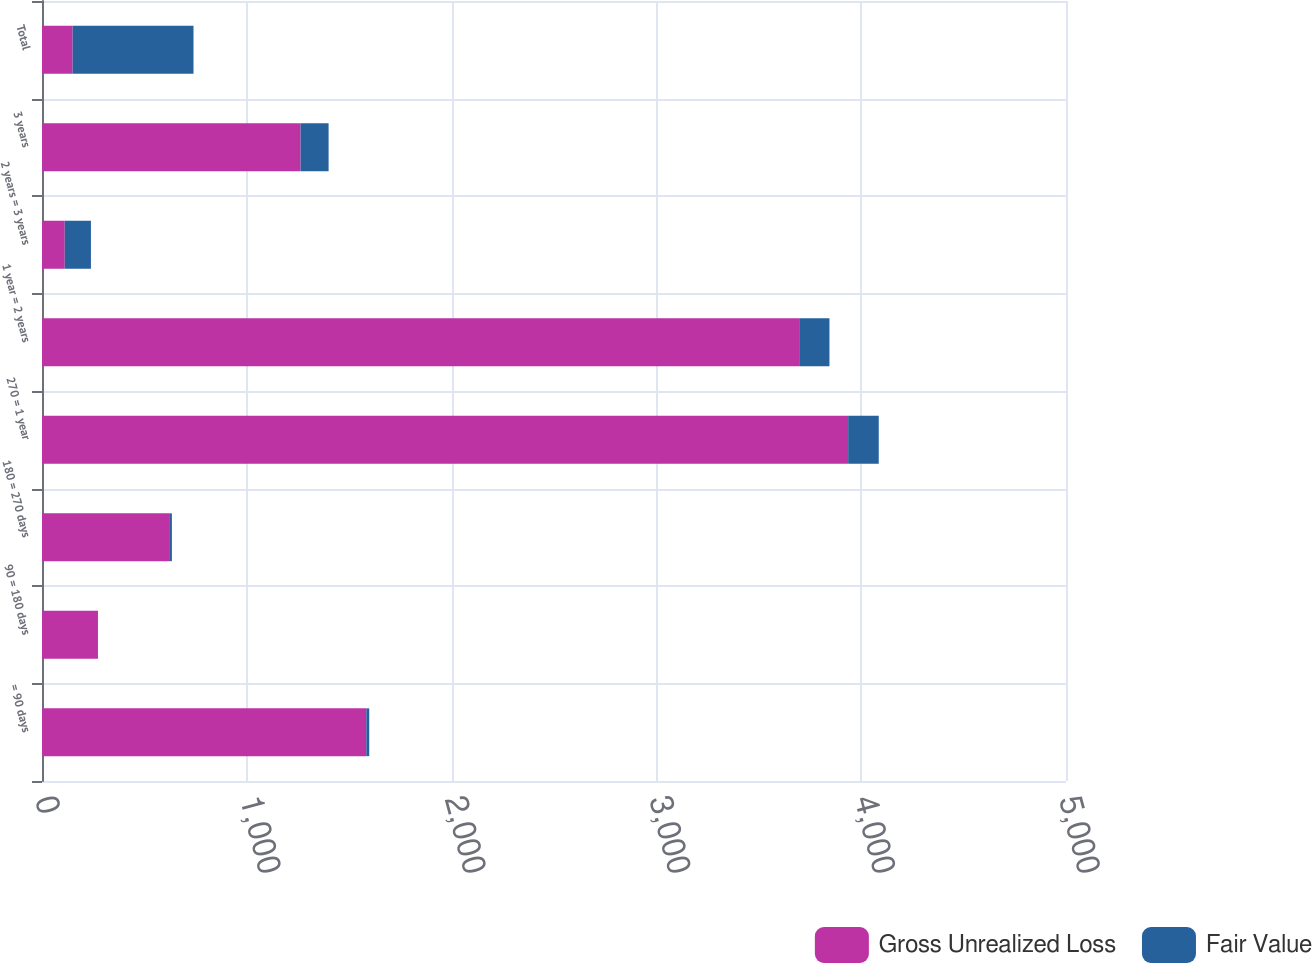Convert chart. <chart><loc_0><loc_0><loc_500><loc_500><stacked_bar_chart><ecel><fcel>= 90 days<fcel>90 = 180 days<fcel>180 = 270 days<fcel>270 = 1 year<fcel>1 year = 2 years<fcel>2 years = 3 years<fcel>3 years<fcel>Total<nl><fcel>Gross Unrealized Loss<fcel>1583.4<fcel>268.7<fcel>624.6<fcel>3936.2<fcel>3697.3<fcel>111<fcel>1262.5<fcel>149.5<nl><fcel>Fair Value<fcel>14.4<fcel>4.2<fcel>9.6<fcel>149.5<fcel>147.7<fcel>127.9<fcel>136.9<fcel>590.2<nl></chart> 